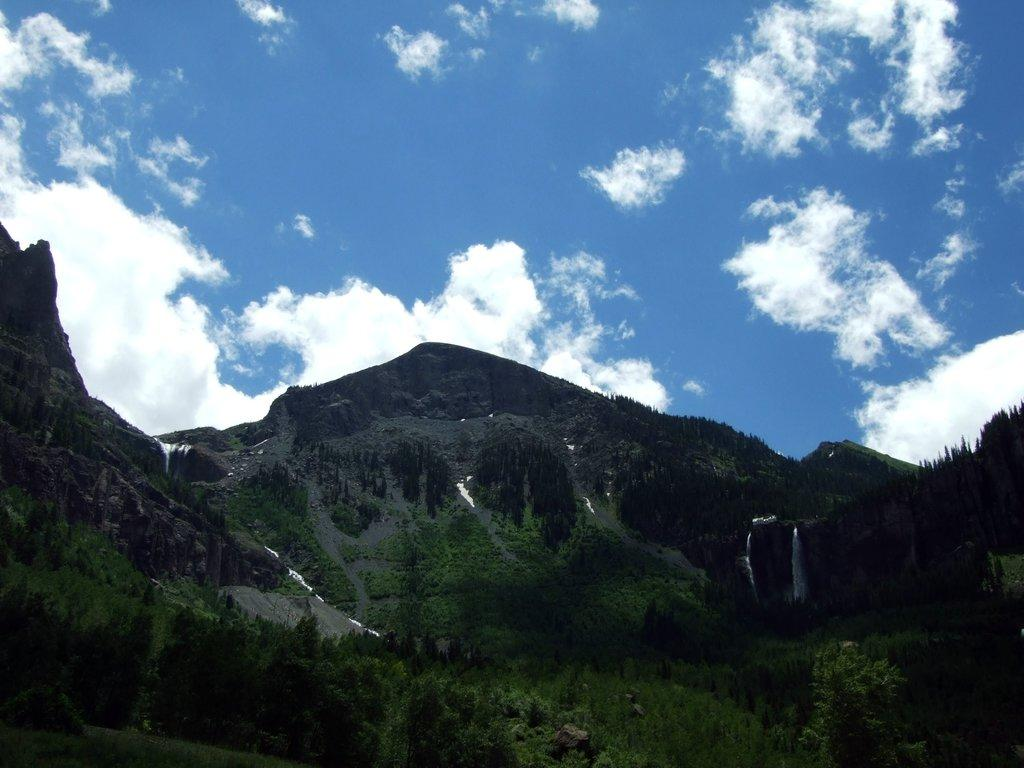What type of natural landscape is depicted in the image? The image features mountains. What other natural elements can be seen in the image? There are trees visible in the image. What is the color of the sky in the background of the image? The sky is visible in the background of the image, and it is blue. Can you see a kitten playing with its eyes in the image? There is no kitten or any reference to eyes playing in the image; it features mountains and trees. What type of ocean creatures can be seen swimming in the image? There is no ocean or any sea creatures present in the image. 